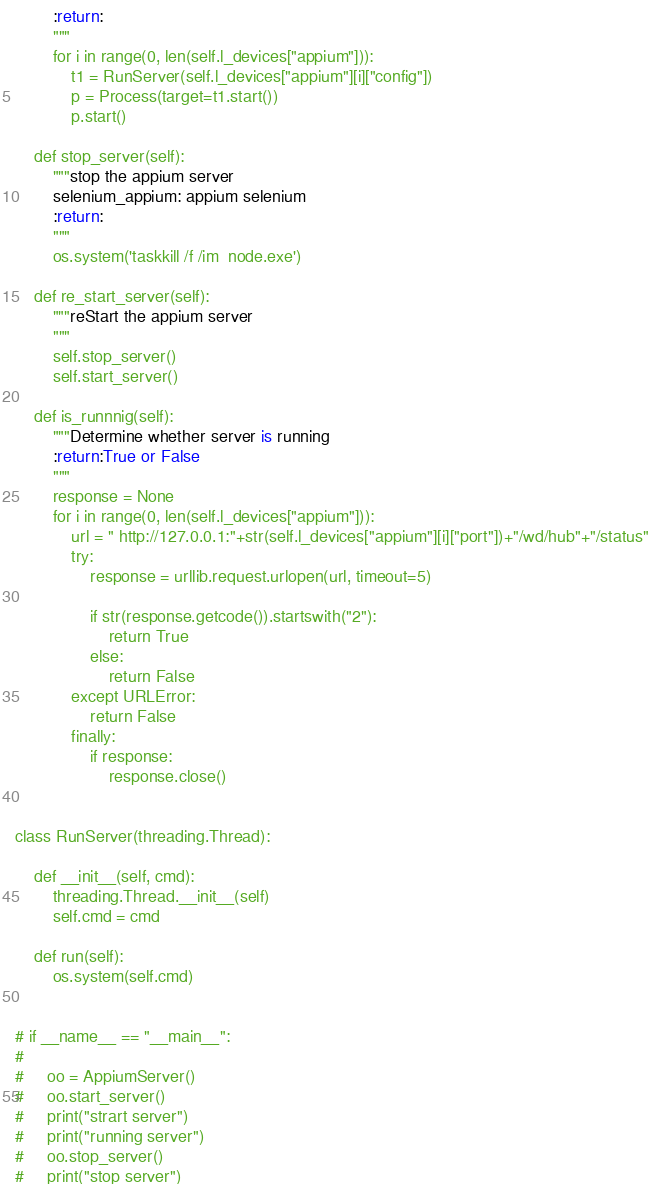<code> <loc_0><loc_0><loc_500><loc_500><_Python_>        :return:
        """
        for i in range(0, len(self.l_devices["appium"])):
            t1 = RunServer(self.l_devices["appium"][i]["config"])
            p = Process(target=t1.start())
            p.start()

    def stop_server(self):
        """stop the appium server
        selenium_appium: appium selenium
        :return:
        """
        os.system('taskkill /f /im  node.exe')

    def re_start_server(self):
        """reStart the appium server
        """
        self.stop_server()
        self.start_server()

    def is_runnnig(self):
        """Determine whether server is running
        :return:True or False
        """
        response = None
        for i in range(0, len(self.l_devices["appium"])):
            url = " http://127.0.0.1:"+str(self.l_devices["appium"][i]["port"])+"/wd/hub"+"/status"
            try:
                response = urllib.request.urlopen(url, timeout=5)

                if str(response.getcode()).startswith("2"):
                    return True
                else:
                    return False
            except URLError:
                return False
            finally:
                if response:
                    response.close()


class RunServer(threading.Thread):

    def __init__(self, cmd):
        threading.Thread.__init__(self)
        self.cmd = cmd

    def run(self):
        os.system(self.cmd)


# if __name__ == "__main__":
#
#     oo = AppiumServer()
#     oo.start_server()
#     print("strart server")
#     print("running server")
#     oo.stop_server()
#     print("stop server")</code> 